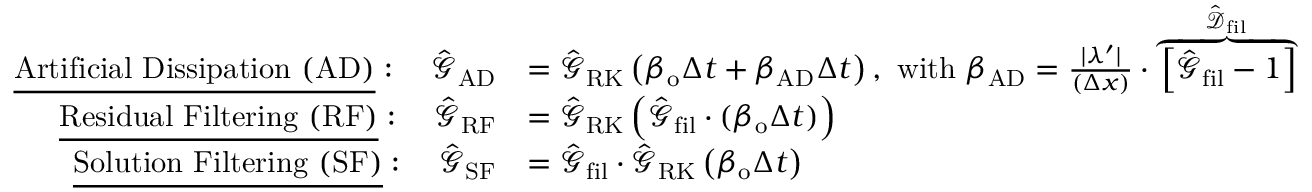Convert formula to latex. <formula><loc_0><loc_0><loc_500><loc_500>\begin{array} { r l } { \underline { A r t i f i c i a l D i s s i p a t i o n ( A D ) } \colon \quad \hat { \mathcal { G } } _ { A D } } & { = \hat { \mathcal { G } } _ { R K } \left ( \beta _ { o } \Delta t + \beta _ { A D } \Delta t \right ) , \ w i t h \ \beta _ { A D } = \frac { | \lambda ^ { \prime } | } { ( \Delta x ) } \cdot \overbrace { \left [ \hat { \mathcal { G } } _ { f i l } - 1 \right ] } ^ { \hat { \mathcal { D } } _ { f i l } } } \\ { \underline { R e s i d u a l F i l t e r i n g ( R F ) } \colon \quad \hat { \mathcal { G } } _ { R F } } & { = \hat { \mathcal { G } } _ { R K } \left ( \hat { \mathcal { G } } _ { f i l } \cdot ( \beta _ { o } \Delta t ) \right ) } \\ { \underline { S o l u t i o n F i l t e r i n g ( S F ) } \colon \quad \hat { \mathcal { G } } _ { S F } } & { = \hat { \mathcal { G } } _ { f i l } \cdot \hat { \mathcal { G } } _ { R K } \left ( \beta _ { o } \Delta t \right ) } \end{array}</formula> 